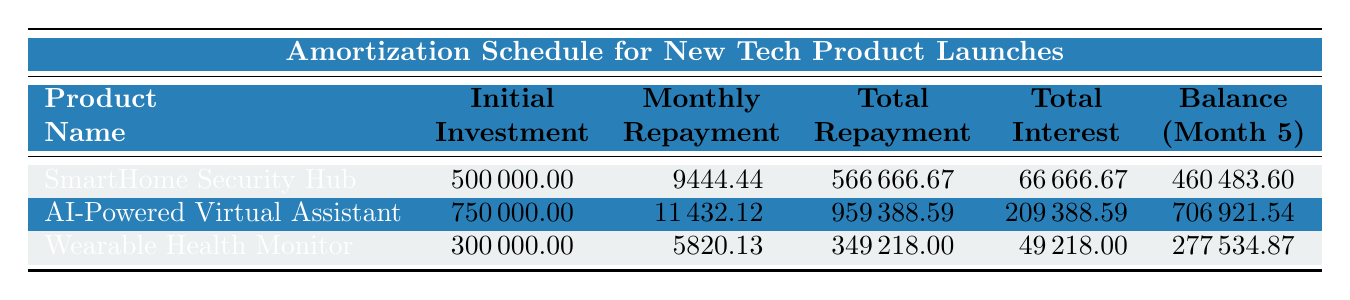What is the initial investment for the AI-Powered Virtual Assistant? The value for the initial investment in the row corresponding to the AI-Powered Virtual Assistant is 750,000.00.
Answer: 750000.00 What is the total repayment amount for the SmartHome Security Hub? The total repayment for the SmartHome Security Hub can be found in the corresponding row which shows 566,666.67.
Answer: 566666.67 Is the total interest paid for the Wearable Health Monitor greater than 50,000? The total interest for the Wearable Health Monitor is 49,218.00, which is less than 50,000, so the answer is no.
Answer: No What is the average monthly repayment amount of all three tech products? The average monthly repayment is calculated by summing the repayments: 9,444.44 + 11,432.12 + 5,820.13 = 26,696.69, then dividing by 3 gives 26,696.69 / 3 = 8,898.90.
Answer: 8898.90 Which product has the highest total interest and what is that amount? The product with the highest total interest is the AI-Powered Virtual Assistant with a total interest of 209,388.59, as shown in the total interest column.
Answer: 209388.59 What will be the outstanding balance for the Wearable Health Monitor after the fifth payment? The outstanding balance is outlined in the table for the Wearable Health Monitor after the fifth payment, which is 277,534.87.
Answer: 277534.87 How much total interest will be paid for the SmartHome Security Hub compared to the total interest for the Wearable Health Monitor? The total interest paid for the SmartHome Security Hub is 66,666.67 and the Wearable Health Monitor is 49,218.00. The difference is 66,666.67 - 49,218.00 = 17,448.67, so the SmartHome Security Hub has 17,448.67 more in interest.
Answer: 17448.67 Will the monthly repayment for the AI-Powered Virtual Assistant exceed 12,000? The monthly repayment for the AI-Powered Virtual Assistant is 11,432.12, which does not exceed 12,000, making the answer no.
Answer: No What is the principal amount paid in the first month for the SmartHome Security Hub? The principal for the first month payment of the SmartHome Security Hub is listed as 8,044.44 in the amortization schedule.
Answer: 8044.44 What is the balance remaining after the second payment for the Wearable Health Monitor? The balance remaining after the second payment for the Wearable Health Monitor is shown in the schedule as 291,078.31.
Answer: 291078.31 